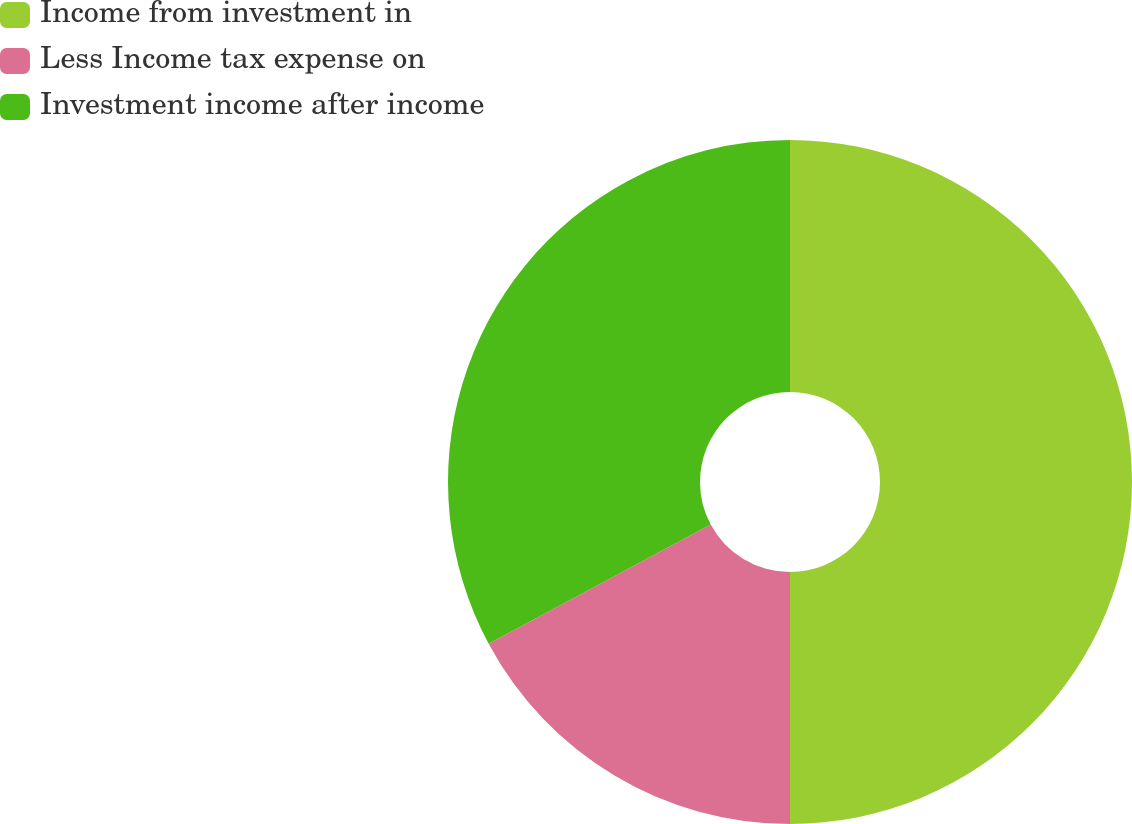Convert chart. <chart><loc_0><loc_0><loc_500><loc_500><pie_chart><fcel>Income from investment in<fcel>Less Income tax expense on<fcel>Investment income after income<nl><fcel>50.0%<fcel>17.16%<fcel>32.84%<nl></chart> 